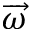Convert formula to latex. <formula><loc_0><loc_0><loc_500><loc_500>\overrightarrow { \omega }</formula> 